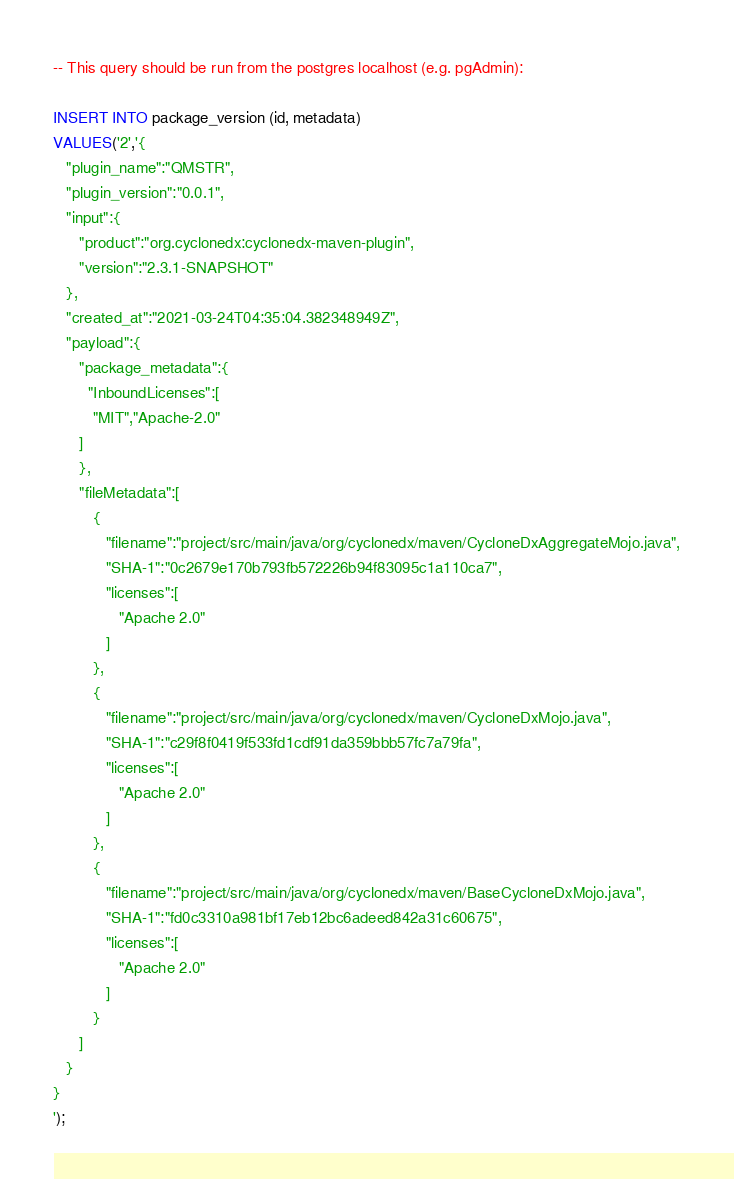Convert code to text. <code><loc_0><loc_0><loc_500><loc_500><_SQL_>-- This query should be run from the postgres localhost (e.g. pgAdmin):

INSERT INTO package_version (id, metadata)
VALUES('2','{
   "plugin_name":"QMSTR",
   "plugin_version":"0.0.1",
   "input":{
      "product":"org.cyclonedx:cyclonedx-maven-plugin",
      "version":"2.3.1-SNAPSHOT"
   },
   "created_at":"2021-03-24T04:35:04.382348949Z",
   "payload":{
      "package_metadata":{
        "InboundLicenses":[
         "MIT","Apache-2.0"
      ]
      },
      "fileMetadata":[
         {
            "filename":"project/src/main/java/org/cyclonedx/maven/CycloneDxAggregateMojo.java",
            "SHA-1":"0c2679e170b793fb572226b94f83095c1a110ca7",
            "licenses":[
               "Apache 2.0"
            ]
         },
         {
            "filename":"project/src/main/java/org/cyclonedx/maven/CycloneDxMojo.java",
            "SHA-1":"c29f8f0419f533fd1cdf91da359bbb57fc7a79fa",
            "licenses":[
               "Apache 2.0"
            ]
         },
         {
            "filename":"project/src/main/java/org/cyclonedx/maven/BaseCycloneDxMojo.java",
            "SHA-1":"fd0c3310a981bf17eb12bc6adeed842a31c60675",
            "licenses":[
               "Apache 2.0"
            ]
         }
      ]
   }
}
');
</code> 